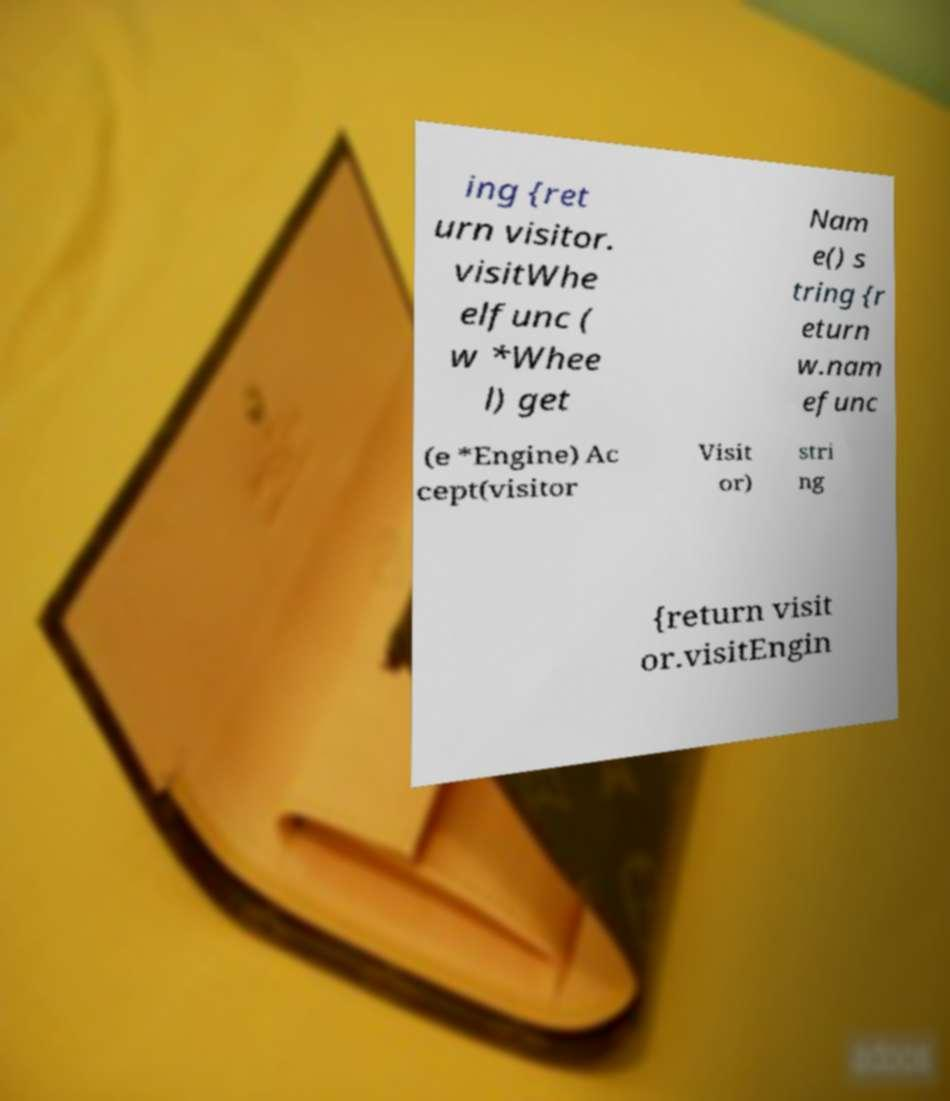There's text embedded in this image that I need extracted. Can you transcribe it verbatim? ing {ret urn visitor. visitWhe elfunc ( w *Whee l) get Nam e() s tring {r eturn w.nam efunc (e *Engine) Ac cept(visitor Visit or) stri ng {return visit or.visitEngin 